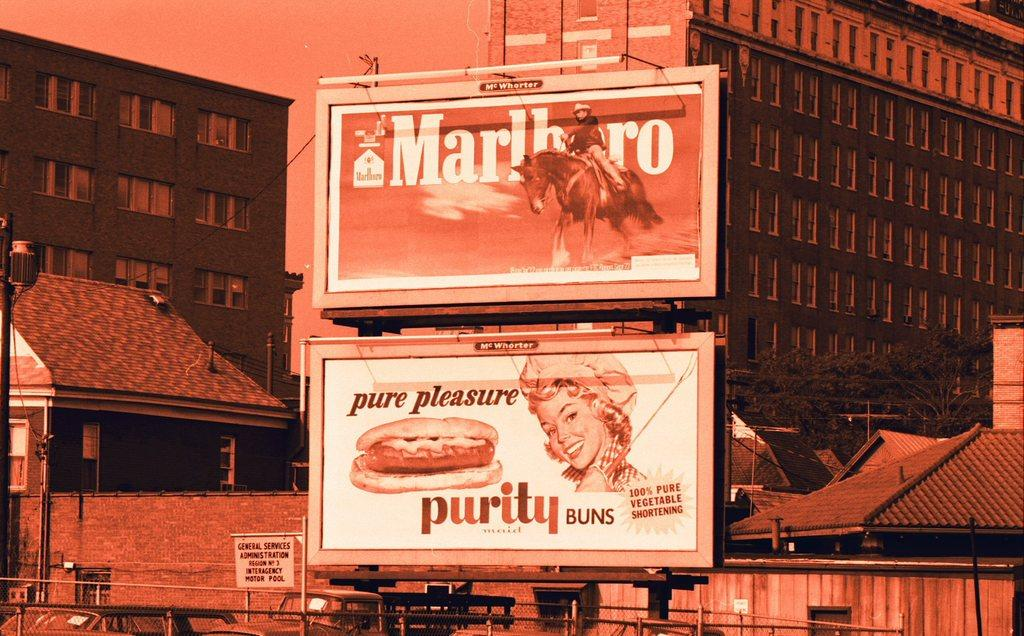<image>
Give a short and clear explanation of the subsequent image. a billboard sign above another sign that says 'pure pleasure purity buns' 